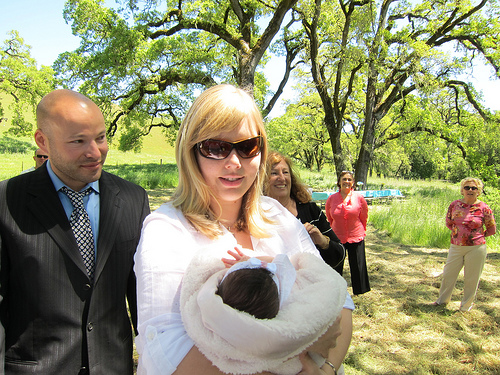<image>
Is the woman in front of the man? No. The woman is not in front of the man. The spatial positioning shows a different relationship between these objects. 